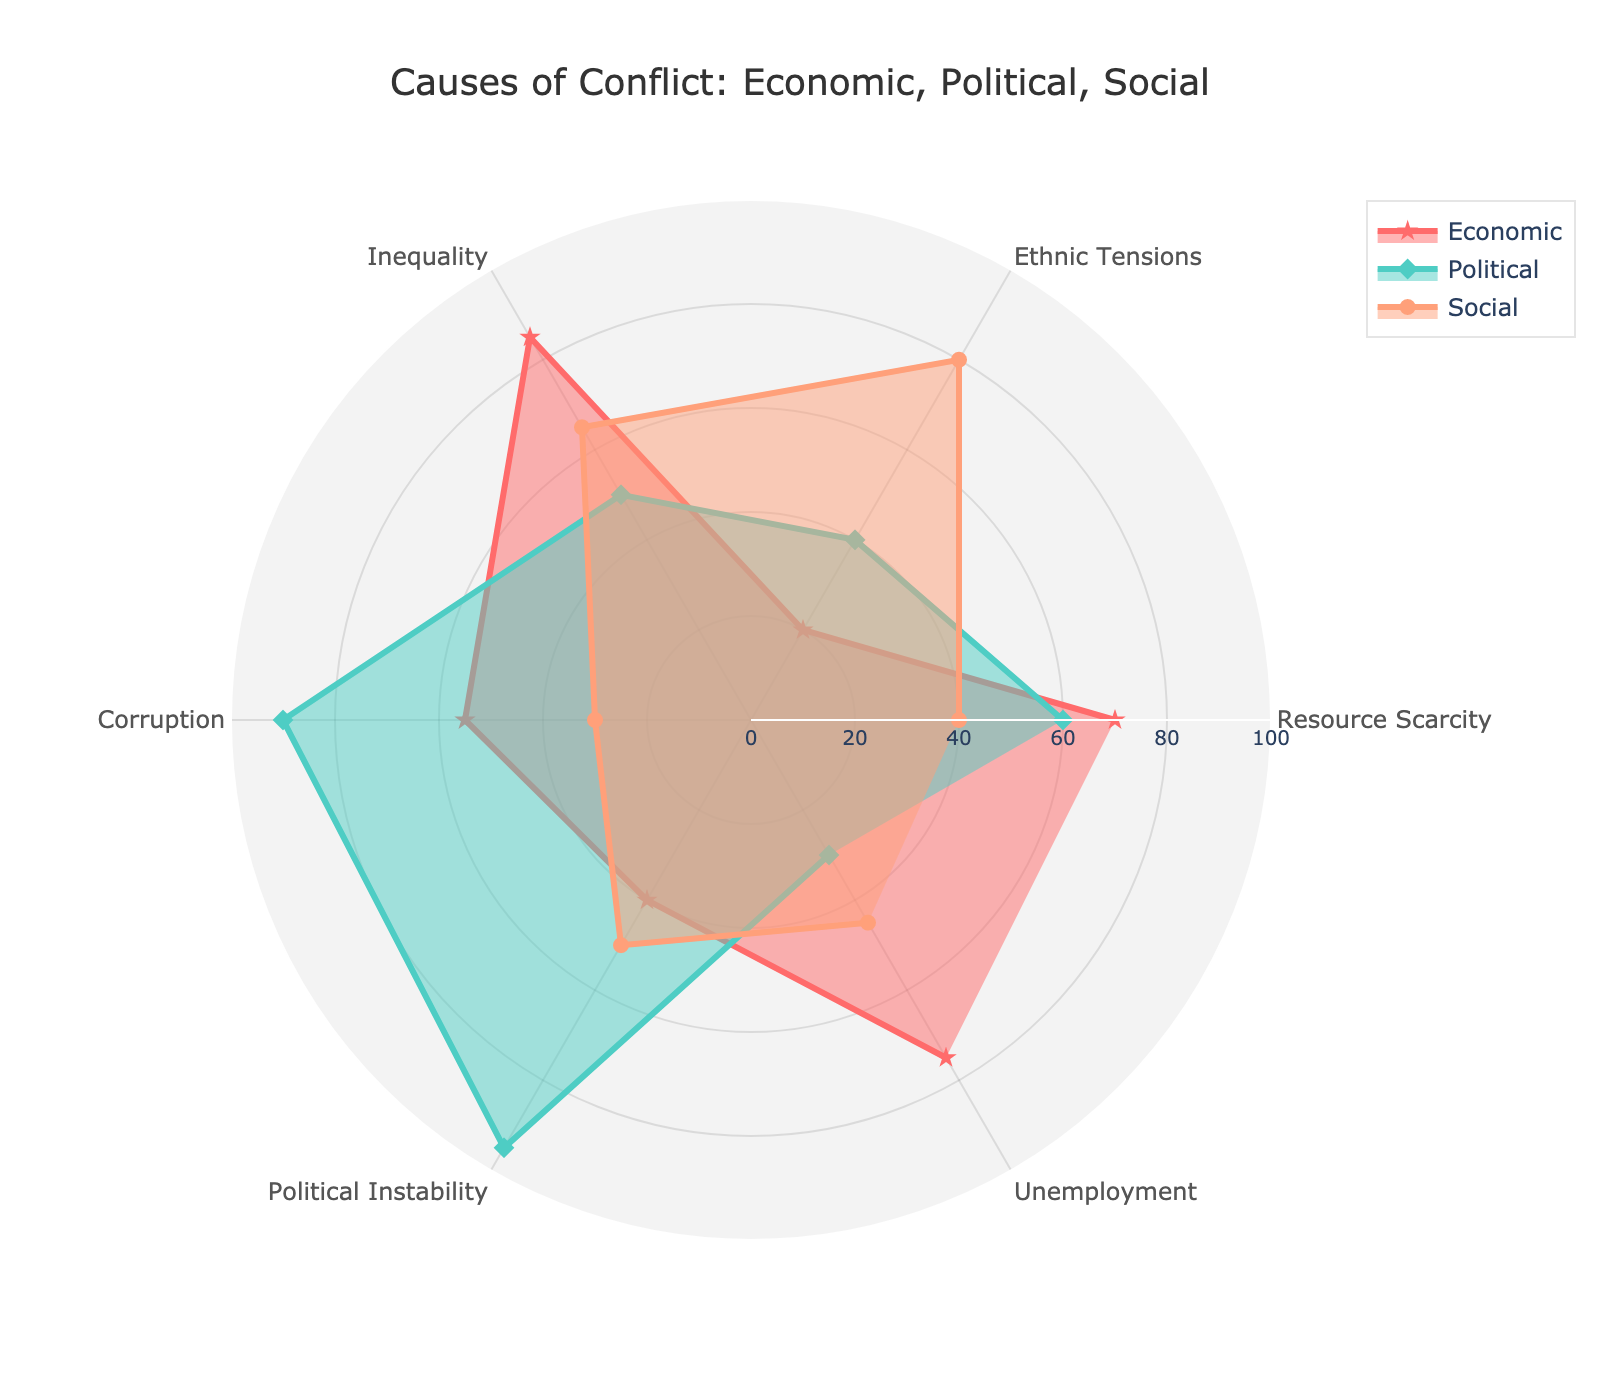What's the title of the radar chart? The title of the radar chart is prominently displayed at the top of the figure, reading "Causes of Conflict: Economic, Political, Social".
Answer: Causes of Conflict: Economic, Political, Social Which cause of conflict has the highest economic impact? By analyzing the radar chart, we can see that "Inequality" has the highest value in the Economic dimension, with a score of 85.
Answer: Inequality What is the average social impact score across all categories? To find the average, sum all social impact scores: 40 (Resource Scarcity) + 80 (Ethnic Tensions) + 65 (Inequality) + 30 (Corruption) + 50 (Political Instability) + 45 (Unemployment) = 310. There are 6 categories, so the average is 310/6.
Answer: 51.67 Is Political Instability more impacted by political or economic factors? The radar chart shows that Political Instability has a political score of 95 and an economic score of 40. Since 95 is greater than 40, Political Instability is more impacted by political factors.
Answer: Political Which cause of conflict has the lowest social impact? By looking at the social scores on the radar chart, "Corruption" has the lowest social impact with a score of 30.
Answer: Corruption How does the economic impact of Resource Scarcity compare to its social impact? Resource Scarcity has an economic impact score of 70 and a social impact score of 40. Since 70 is greater than 40, its economic impact is higher than its social impact.
Answer: Economic impact is higher Which category is most impacted by political factors? Checking all the political scores on the radar chart, "Political Instability" has the highest score with 95.
Answer: Political Instability What's the combined impact score of Corruption for economic and social factors? To find the combined impact, sum the economic and social scores of Corruption: 55 (Economic) + 30 (Social) = 85.
Answer: 85 What is the range of economic impact scores in the chart? Finding the minimum and maximum economic scores: the lowest is 20 (Ethnic Tensions) and the highest is 85 (Inequality). The range is 85 - 20.
Answer: 65 Do any categories show an equal score for any two factors? By examining the radar chart, no categories show equal scores among the economic, political, and social factors.
Answer: No 